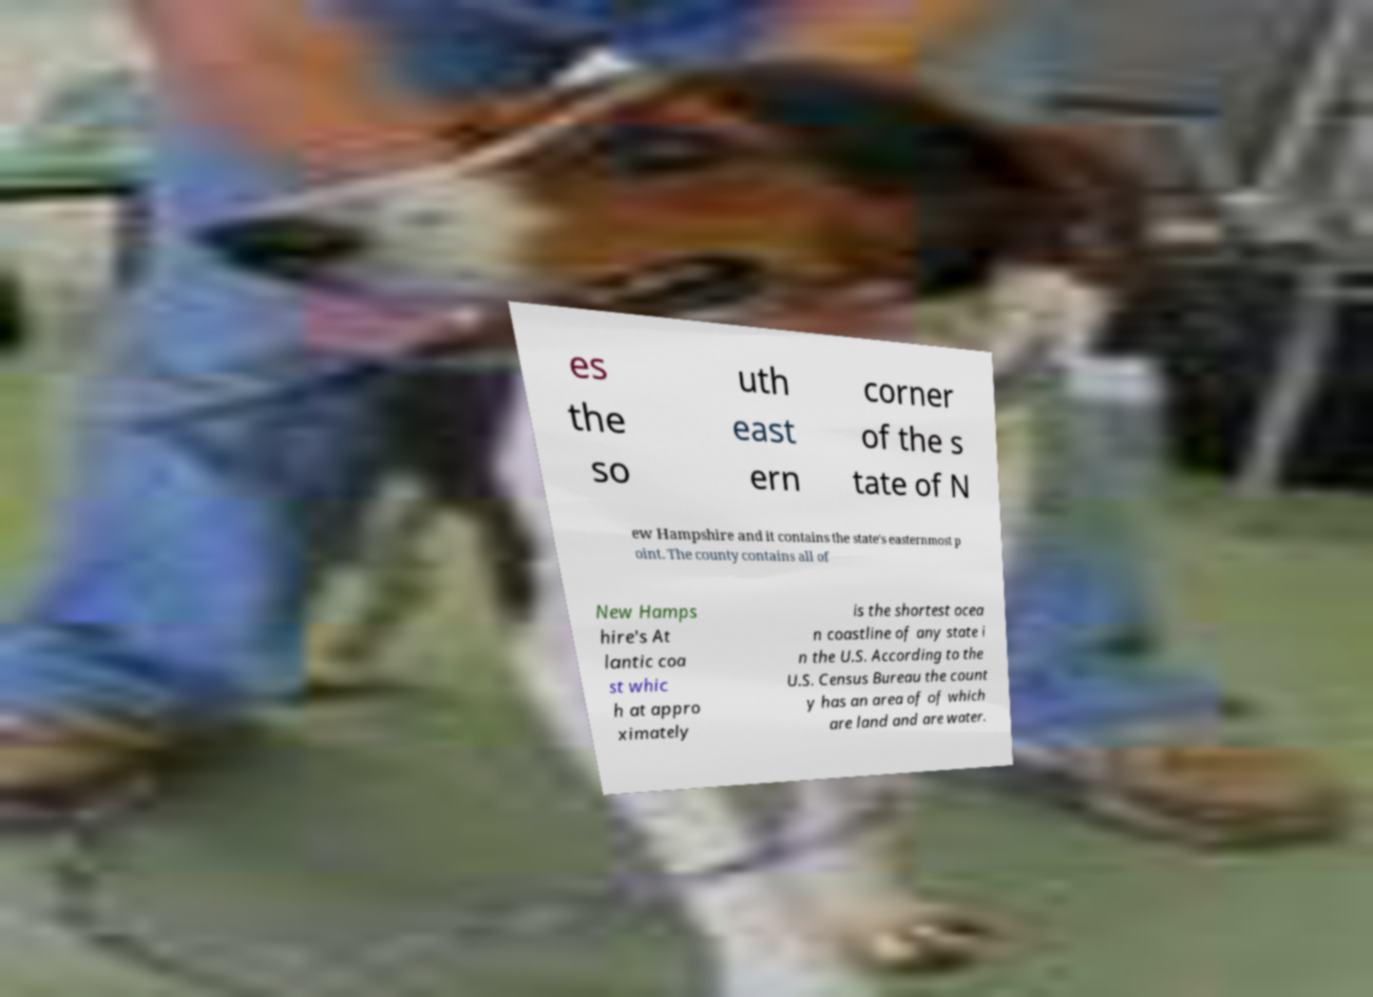Can you accurately transcribe the text from the provided image for me? es the so uth east ern corner of the s tate of N ew Hampshire and it contains the state's easternmost p oint. The county contains all of New Hamps hire's At lantic coa st whic h at appro ximately is the shortest ocea n coastline of any state i n the U.S. According to the U.S. Census Bureau the count y has an area of of which are land and are water. 